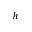<formula> <loc_0><loc_0><loc_500><loc_500>^ { h }</formula> 